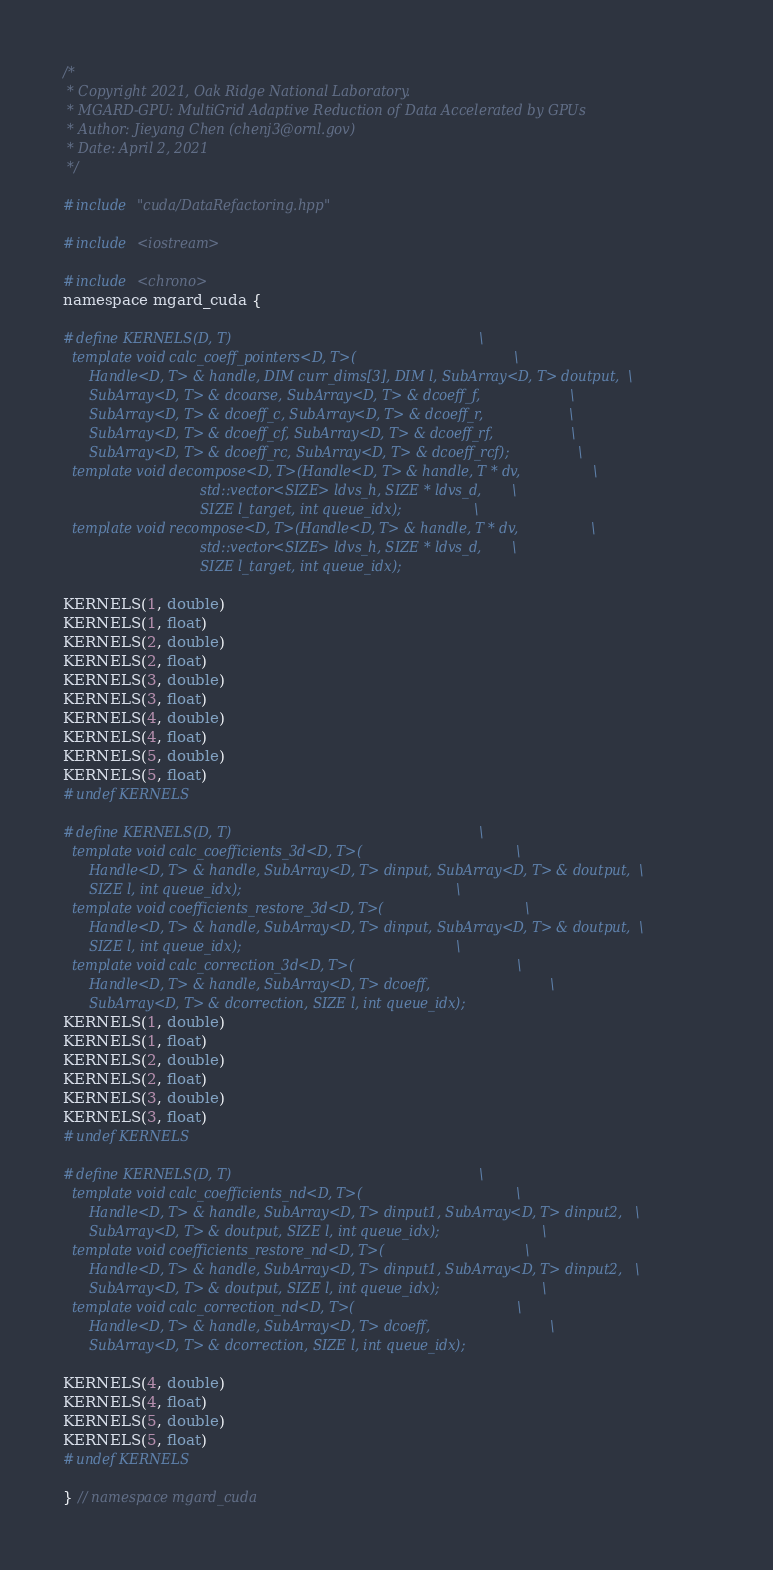<code> <loc_0><loc_0><loc_500><loc_500><_Cuda_>/*
 * Copyright 2021, Oak Ridge National Laboratory.
 * MGARD-GPU: MultiGrid Adaptive Reduction of Data Accelerated by GPUs
 * Author: Jieyang Chen (chenj3@ornl.gov)
 * Date: April 2, 2021
 */

#include "cuda/DataRefactoring.hpp"

#include <iostream>

#include <chrono>
namespace mgard_cuda {

#define KERNELS(D, T)                                                          \
  template void calc_coeff_pointers<D, T>(                                     \
      Handle<D, T> & handle, DIM curr_dims[3], DIM l, SubArray<D, T> doutput,  \
      SubArray<D, T> & dcoarse, SubArray<D, T> & dcoeff_f,                     \
      SubArray<D, T> & dcoeff_c, SubArray<D, T> & dcoeff_r,                    \
      SubArray<D, T> & dcoeff_cf, SubArray<D, T> & dcoeff_rf,                  \
      SubArray<D, T> & dcoeff_rc, SubArray<D, T> & dcoeff_rcf);                \
  template void decompose<D, T>(Handle<D, T> & handle, T * dv,                 \
                                std::vector<SIZE> ldvs_h, SIZE * ldvs_d,       \
                                SIZE l_target, int queue_idx);                 \
  template void recompose<D, T>(Handle<D, T> & handle, T * dv,                 \
                                std::vector<SIZE> ldvs_h, SIZE * ldvs_d,       \
                                SIZE l_target, int queue_idx);

KERNELS(1, double)
KERNELS(1, float)
KERNELS(2, double)
KERNELS(2, float)
KERNELS(3, double)
KERNELS(3, float)
KERNELS(4, double)
KERNELS(4, float)
KERNELS(5, double)
KERNELS(5, float)
#undef KERNELS

#define KERNELS(D, T)                                                          \
  template void calc_coefficients_3d<D, T>(                                    \
      Handle<D, T> & handle, SubArray<D, T> dinput, SubArray<D, T> & doutput,  \
      SIZE l, int queue_idx);                                                  \
  template void coefficients_restore_3d<D, T>(                                 \
      Handle<D, T> & handle, SubArray<D, T> dinput, SubArray<D, T> & doutput,  \
      SIZE l, int queue_idx);                                                  \
  template void calc_correction_3d<D, T>(                                      \
      Handle<D, T> & handle, SubArray<D, T> dcoeff,                            \
      SubArray<D, T> & dcorrection, SIZE l, int queue_idx);
KERNELS(1, double)
KERNELS(1, float)
KERNELS(2, double)
KERNELS(2, float)
KERNELS(3, double)
KERNELS(3, float)
#undef KERNELS

#define KERNELS(D, T)                                                          \
  template void calc_coefficients_nd<D, T>(                                    \
      Handle<D, T> & handle, SubArray<D, T> dinput1, SubArray<D, T> dinput2,   \
      SubArray<D, T> & doutput, SIZE l, int queue_idx);                        \
  template void coefficients_restore_nd<D, T>(                                 \
      Handle<D, T> & handle, SubArray<D, T> dinput1, SubArray<D, T> dinput2,   \
      SubArray<D, T> & doutput, SIZE l, int queue_idx);                        \
  template void calc_correction_nd<D, T>(                                      \
      Handle<D, T> & handle, SubArray<D, T> dcoeff,                            \
      SubArray<D, T> & dcorrection, SIZE l, int queue_idx);

KERNELS(4, double)
KERNELS(4, float)
KERNELS(5, double)
KERNELS(5, float)
#undef KERNELS

} // namespace mgard_cuda
</code> 